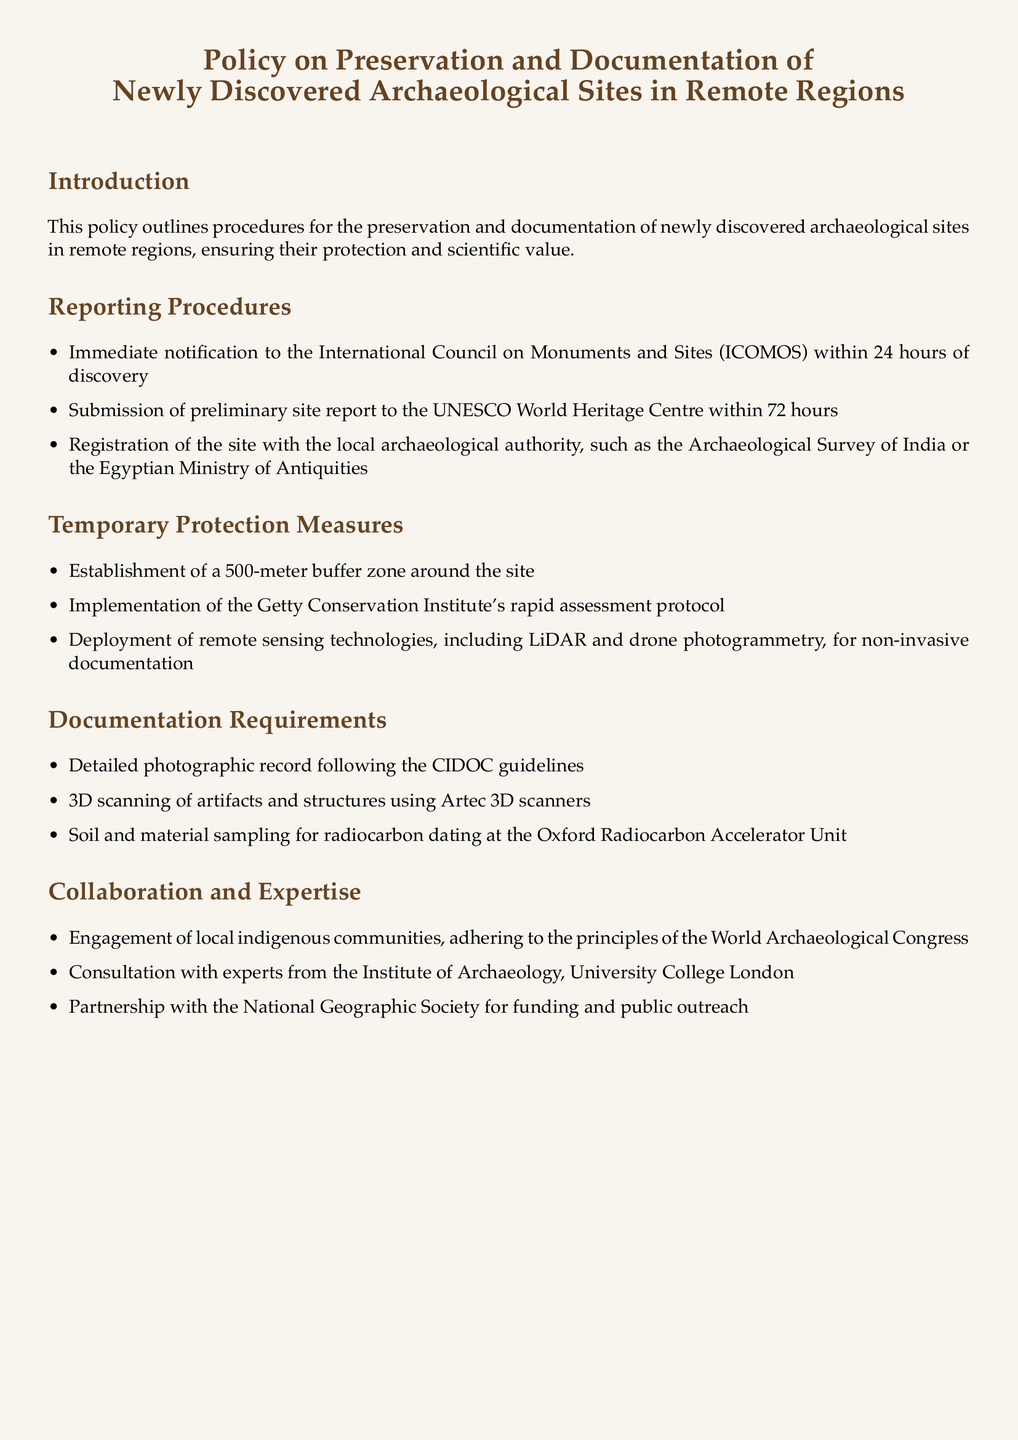What is the first organization to be notified after a discovery? The document states that immediate notification must be made to the International Council on Monuments and Sites (ICOMOS) within 24 hours of discovery.
Answer: ICOMOS What is the submission deadline for the preliminary site report? According to the policies, the preliminary site report must be submitted to the UNESCO World Heritage Centre within 72 hours.
Answer: 72 hours What is the buffer zone size established around the site? The policy specifies the establishment of a 500-meter buffer zone around the site.
Answer: 500 meters Which institute's rapid assessment protocol is to be implemented? The document mentions the Getty Conservation Institute's rapid assessment protocol to be implemented as part of temporary protection measures.
Answer: Getty Conservation Institute What type of technology is recommended for non-invasive documentation? The policy suggests deploying remote sensing technologies, including LiDAR and drone photogrammetry, for non-invasive documentation.
Answer: LiDAR and drone photogrammetry What type of communities should be engaged according to the policy? The document emphasizes the engagement of local indigenous communities while adhering to certain principles.
Answer: Local indigenous communities Which university is mentioned for consultation with experts? The document states consulting with experts from the Institute of Archaeology, University College London.
Answer: University College London What value does this policy aim to ensure for newly discovered sites? The policy aims to ensure both protection and scientific value for newly discovered archaeological sites.
Answer: Protection and scientific value 